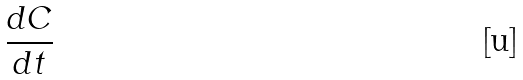<formula> <loc_0><loc_0><loc_500><loc_500>\frac { d C } { d t }</formula> 